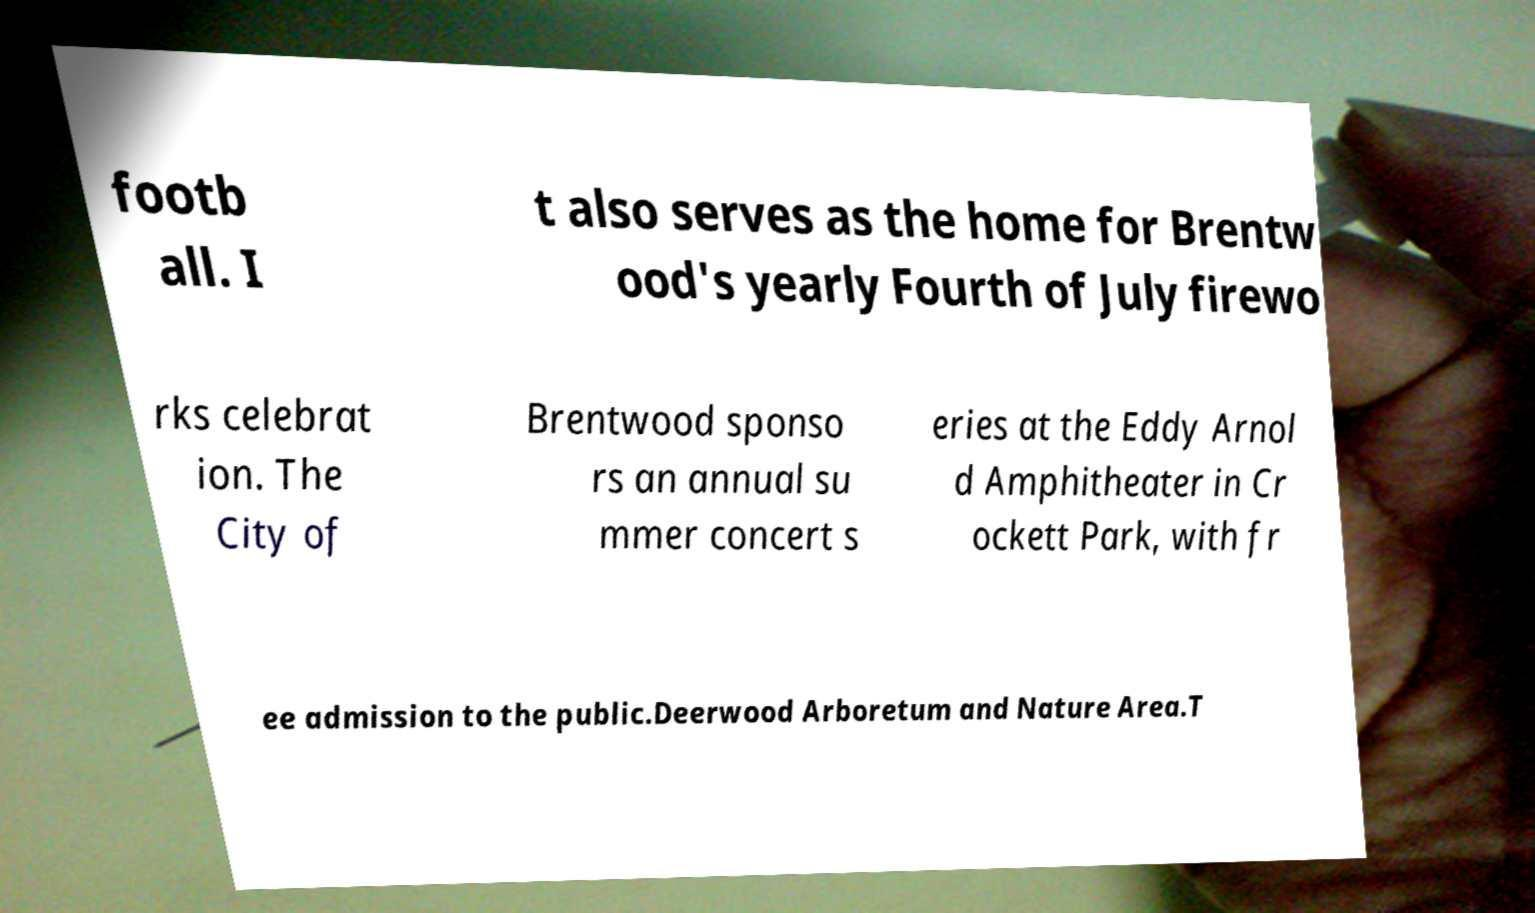Could you assist in decoding the text presented in this image and type it out clearly? footb all. I t also serves as the home for Brentw ood's yearly Fourth of July firewo rks celebrat ion. The City of Brentwood sponso rs an annual su mmer concert s eries at the Eddy Arnol d Amphitheater in Cr ockett Park, with fr ee admission to the public.Deerwood Arboretum and Nature Area.T 